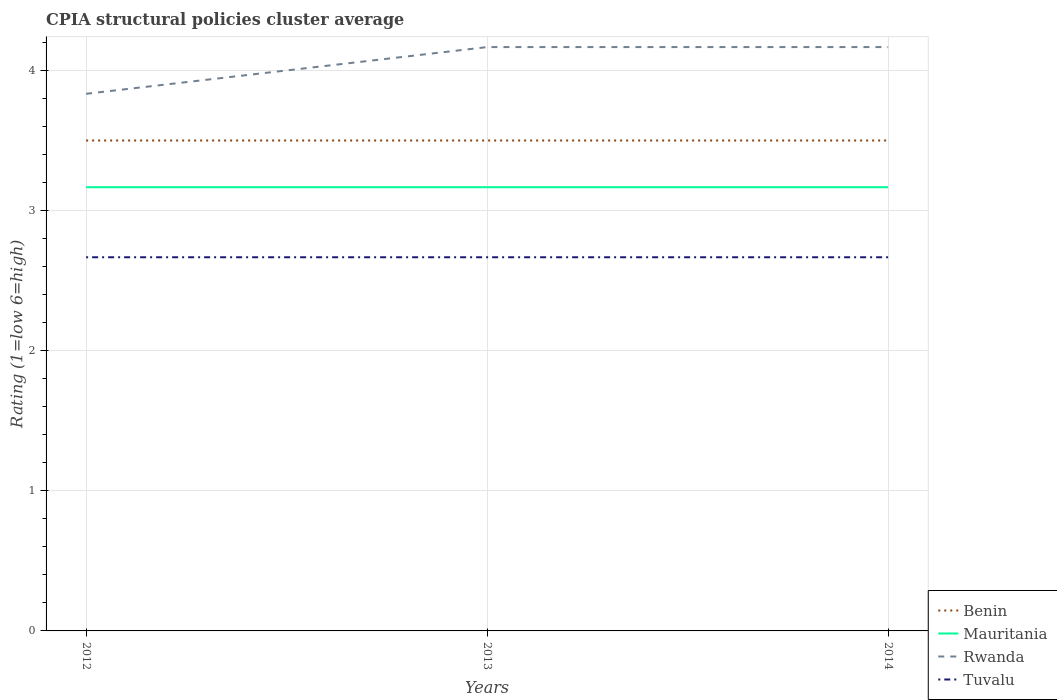How many different coloured lines are there?
Keep it short and to the point. 4. Is the number of lines equal to the number of legend labels?
Your answer should be compact. Yes. Across all years, what is the maximum CPIA rating in Rwanda?
Provide a short and direct response. 3.83. In which year was the CPIA rating in Tuvalu maximum?
Provide a succinct answer. 2012. What is the total CPIA rating in Benin in the graph?
Provide a short and direct response. 0. What is the difference between the highest and the second highest CPIA rating in Mauritania?
Give a very brief answer. 0. Is the CPIA rating in Tuvalu strictly greater than the CPIA rating in Benin over the years?
Give a very brief answer. Yes. How many lines are there?
Your response must be concise. 4. How many years are there in the graph?
Your response must be concise. 3. Are the values on the major ticks of Y-axis written in scientific E-notation?
Your answer should be very brief. No. Where does the legend appear in the graph?
Offer a very short reply. Bottom right. How are the legend labels stacked?
Give a very brief answer. Vertical. What is the title of the graph?
Ensure brevity in your answer.  CPIA structural policies cluster average. What is the label or title of the X-axis?
Your answer should be compact. Years. What is the label or title of the Y-axis?
Provide a short and direct response. Rating (1=low 6=high). What is the Rating (1=low 6=high) in Mauritania in 2012?
Give a very brief answer. 3.17. What is the Rating (1=low 6=high) of Rwanda in 2012?
Your answer should be compact. 3.83. What is the Rating (1=low 6=high) in Tuvalu in 2012?
Your answer should be compact. 2.67. What is the Rating (1=low 6=high) in Benin in 2013?
Ensure brevity in your answer.  3.5. What is the Rating (1=low 6=high) in Mauritania in 2013?
Your answer should be compact. 3.17. What is the Rating (1=low 6=high) in Rwanda in 2013?
Your response must be concise. 4.17. What is the Rating (1=low 6=high) in Tuvalu in 2013?
Give a very brief answer. 2.67. What is the Rating (1=low 6=high) of Benin in 2014?
Give a very brief answer. 3.5. What is the Rating (1=low 6=high) in Mauritania in 2014?
Ensure brevity in your answer.  3.17. What is the Rating (1=low 6=high) in Rwanda in 2014?
Provide a short and direct response. 4.17. What is the Rating (1=low 6=high) in Tuvalu in 2014?
Give a very brief answer. 2.67. Across all years, what is the maximum Rating (1=low 6=high) in Benin?
Provide a short and direct response. 3.5. Across all years, what is the maximum Rating (1=low 6=high) of Mauritania?
Your answer should be very brief. 3.17. Across all years, what is the maximum Rating (1=low 6=high) in Rwanda?
Your answer should be very brief. 4.17. Across all years, what is the maximum Rating (1=low 6=high) of Tuvalu?
Your response must be concise. 2.67. Across all years, what is the minimum Rating (1=low 6=high) of Benin?
Make the answer very short. 3.5. Across all years, what is the minimum Rating (1=low 6=high) of Mauritania?
Provide a short and direct response. 3.17. Across all years, what is the minimum Rating (1=low 6=high) of Rwanda?
Offer a terse response. 3.83. Across all years, what is the minimum Rating (1=low 6=high) in Tuvalu?
Provide a short and direct response. 2.67. What is the total Rating (1=low 6=high) in Mauritania in the graph?
Your response must be concise. 9.5. What is the total Rating (1=low 6=high) of Rwanda in the graph?
Give a very brief answer. 12.17. What is the total Rating (1=low 6=high) of Tuvalu in the graph?
Your answer should be very brief. 8. What is the difference between the Rating (1=low 6=high) in Mauritania in 2012 and that in 2013?
Your answer should be very brief. 0. What is the difference between the Rating (1=low 6=high) of Tuvalu in 2012 and that in 2013?
Offer a terse response. 0. What is the difference between the Rating (1=low 6=high) of Mauritania in 2012 and that in 2014?
Your answer should be compact. 0. What is the difference between the Rating (1=low 6=high) of Rwanda in 2013 and that in 2014?
Your response must be concise. -0. What is the difference between the Rating (1=low 6=high) of Tuvalu in 2013 and that in 2014?
Your answer should be compact. -0. What is the difference between the Rating (1=low 6=high) in Benin in 2012 and the Rating (1=low 6=high) in Mauritania in 2013?
Make the answer very short. 0.33. What is the difference between the Rating (1=low 6=high) in Benin in 2012 and the Rating (1=low 6=high) in Tuvalu in 2013?
Offer a very short reply. 0.83. What is the difference between the Rating (1=low 6=high) in Mauritania in 2012 and the Rating (1=low 6=high) in Rwanda in 2013?
Your answer should be compact. -1. What is the difference between the Rating (1=low 6=high) of Benin in 2012 and the Rating (1=low 6=high) of Mauritania in 2014?
Your answer should be compact. 0.33. What is the difference between the Rating (1=low 6=high) of Benin in 2012 and the Rating (1=low 6=high) of Tuvalu in 2014?
Give a very brief answer. 0.83. What is the difference between the Rating (1=low 6=high) of Mauritania in 2012 and the Rating (1=low 6=high) of Tuvalu in 2014?
Provide a succinct answer. 0.5. What is the difference between the Rating (1=low 6=high) of Benin in 2013 and the Rating (1=low 6=high) of Rwanda in 2014?
Provide a succinct answer. -0.67. What is the difference between the Rating (1=low 6=high) of Benin in 2013 and the Rating (1=low 6=high) of Tuvalu in 2014?
Give a very brief answer. 0.83. What is the difference between the Rating (1=low 6=high) in Mauritania in 2013 and the Rating (1=low 6=high) in Rwanda in 2014?
Your answer should be very brief. -1. What is the difference between the Rating (1=low 6=high) in Rwanda in 2013 and the Rating (1=low 6=high) in Tuvalu in 2014?
Provide a succinct answer. 1.5. What is the average Rating (1=low 6=high) in Benin per year?
Make the answer very short. 3.5. What is the average Rating (1=low 6=high) of Mauritania per year?
Offer a terse response. 3.17. What is the average Rating (1=low 6=high) in Rwanda per year?
Make the answer very short. 4.06. What is the average Rating (1=low 6=high) in Tuvalu per year?
Provide a succinct answer. 2.67. In the year 2012, what is the difference between the Rating (1=low 6=high) in Benin and Rating (1=low 6=high) in Mauritania?
Provide a short and direct response. 0.33. In the year 2012, what is the difference between the Rating (1=low 6=high) of Benin and Rating (1=low 6=high) of Tuvalu?
Provide a short and direct response. 0.83. In the year 2013, what is the difference between the Rating (1=low 6=high) in Benin and Rating (1=low 6=high) in Mauritania?
Provide a short and direct response. 0.33. In the year 2013, what is the difference between the Rating (1=low 6=high) in Benin and Rating (1=low 6=high) in Rwanda?
Provide a short and direct response. -0.67. In the year 2013, what is the difference between the Rating (1=low 6=high) in Mauritania and Rating (1=low 6=high) in Rwanda?
Your answer should be compact. -1. In the year 2013, what is the difference between the Rating (1=low 6=high) in Rwanda and Rating (1=low 6=high) in Tuvalu?
Offer a very short reply. 1.5. In the year 2014, what is the difference between the Rating (1=low 6=high) in Benin and Rating (1=low 6=high) in Rwanda?
Your response must be concise. -0.67. In the year 2014, what is the difference between the Rating (1=low 6=high) in Benin and Rating (1=low 6=high) in Tuvalu?
Ensure brevity in your answer.  0.83. In the year 2014, what is the difference between the Rating (1=low 6=high) in Mauritania and Rating (1=low 6=high) in Rwanda?
Make the answer very short. -1. In the year 2014, what is the difference between the Rating (1=low 6=high) of Mauritania and Rating (1=low 6=high) of Tuvalu?
Make the answer very short. 0.5. In the year 2014, what is the difference between the Rating (1=low 6=high) of Rwanda and Rating (1=low 6=high) of Tuvalu?
Make the answer very short. 1.5. What is the ratio of the Rating (1=low 6=high) in Benin in 2012 to that in 2013?
Make the answer very short. 1. What is the ratio of the Rating (1=low 6=high) of Mauritania in 2012 to that in 2013?
Your answer should be compact. 1. What is the ratio of the Rating (1=low 6=high) of Rwanda in 2012 to that in 2013?
Your response must be concise. 0.92. What is the ratio of the Rating (1=low 6=high) of Benin in 2012 to that in 2014?
Offer a very short reply. 1. What is the ratio of the Rating (1=low 6=high) of Mauritania in 2012 to that in 2014?
Ensure brevity in your answer.  1. What is the ratio of the Rating (1=low 6=high) in Tuvalu in 2012 to that in 2014?
Provide a short and direct response. 1. What is the ratio of the Rating (1=low 6=high) in Rwanda in 2013 to that in 2014?
Your response must be concise. 1. What is the difference between the highest and the second highest Rating (1=low 6=high) in Benin?
Ensure brevity in your answer.  0. What is the difference between the highest and the second highest Rating (1=low 6=high) in Mauritania?
Provide a short and direct response. 0. What is the difference between the highest and the lowest Rating (1=low 6=high) in Benin?
Keep it short and to the point. 0. What is the difference between the highest and the lowest Rating (1=low 6=high) in Rwanda?
Provide a short and direct response. 0.33. 